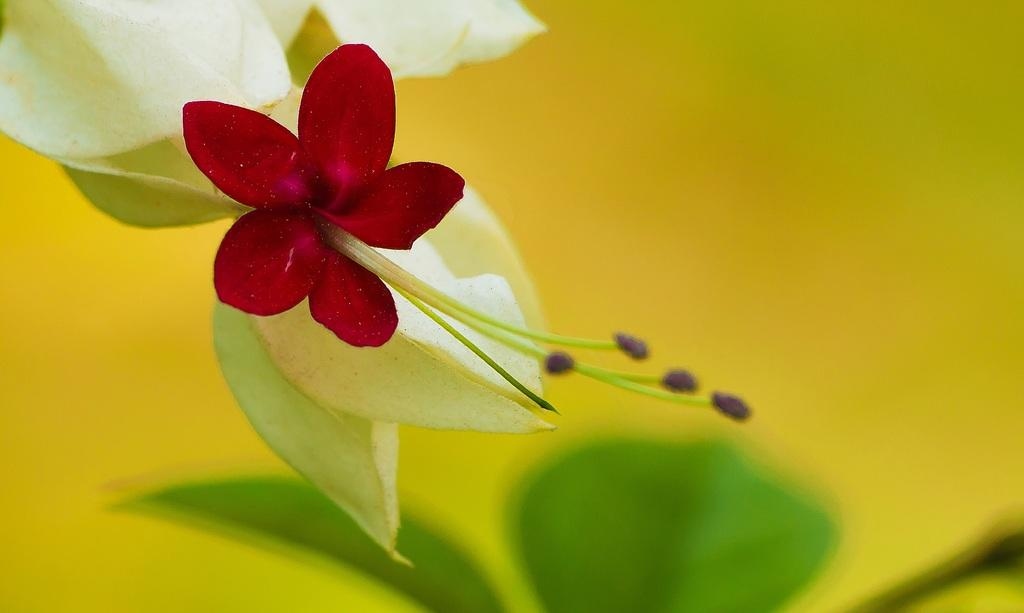What is present in the image? There is a flower in the image. Can you describe the color of the flower? The flower is red in color. What else can be seen in the image besides the flower? There are leaves in the image. Where is the cat sleeping in the image? There is no cat present in the image. What type of nest can be seen in the image? There is no nest present in the image. 